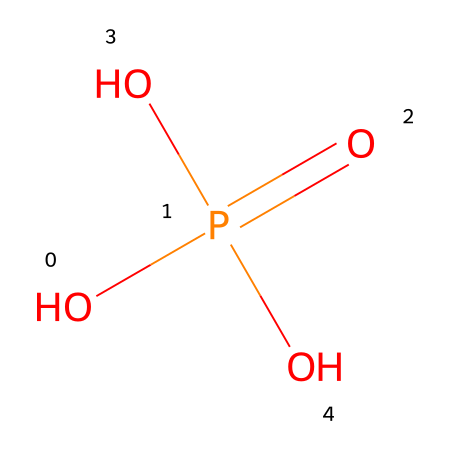What is the name of this chemical? The SMILES representation indicates the presence of a phosphorus atom bonded to oxygen and hydroxyl groups, which corresponds to the well-known compound formed by one phosphorous atom and four oxygen atoms in total, leading to the name phosphoric acid.
Answer: phosphoric acid How many oxygen atoms are in this molecule? Analyzing the SMILES representation, we see there are four oxygen atoms connected to the phosphorus atom (one in a double bond and three single bonds).
Answer: four What type of acid is represented by this chemical structure? This chemical structure includes a central phosphorus atom with hydroxyl groups, which characterizes it as an oxyacid due to its oxygen containing acidic groups. Specifically, since it contains phosphate groups, it is classified as a mineral or inorganic acid.
Answer: mineral acid How many total atoms are in this molecule? By counting the atoms in the SMILES notation, we find one phosphorus, four oxygen, and three hydrogen atoms, resulting in a total of eight atoms (1 phosphorus + 4 oxygen + 3 hydrogen).
Answer: eight What is the oxidation state of phosphorus in this compound? In this chemical structure, we can deduce the oxidation state of phosphorus by considering its surrounding atoms. The phosphorus atom is bonded to four oxygen atoms (with one double bond), giving it an oxidation state of +5 because it loses five electrons in forming these bonds.
Answer: +5 Can this compound act as a buffer in sports drinks? Phosphoric acid can dissociate into multiple hydrogen ions (H+) and has multiple dissociation constants, making it capable of maintaining a stable pH range in solutions, which is a characteristic required to act as a buffer in sports drinks.
Answer: yes 